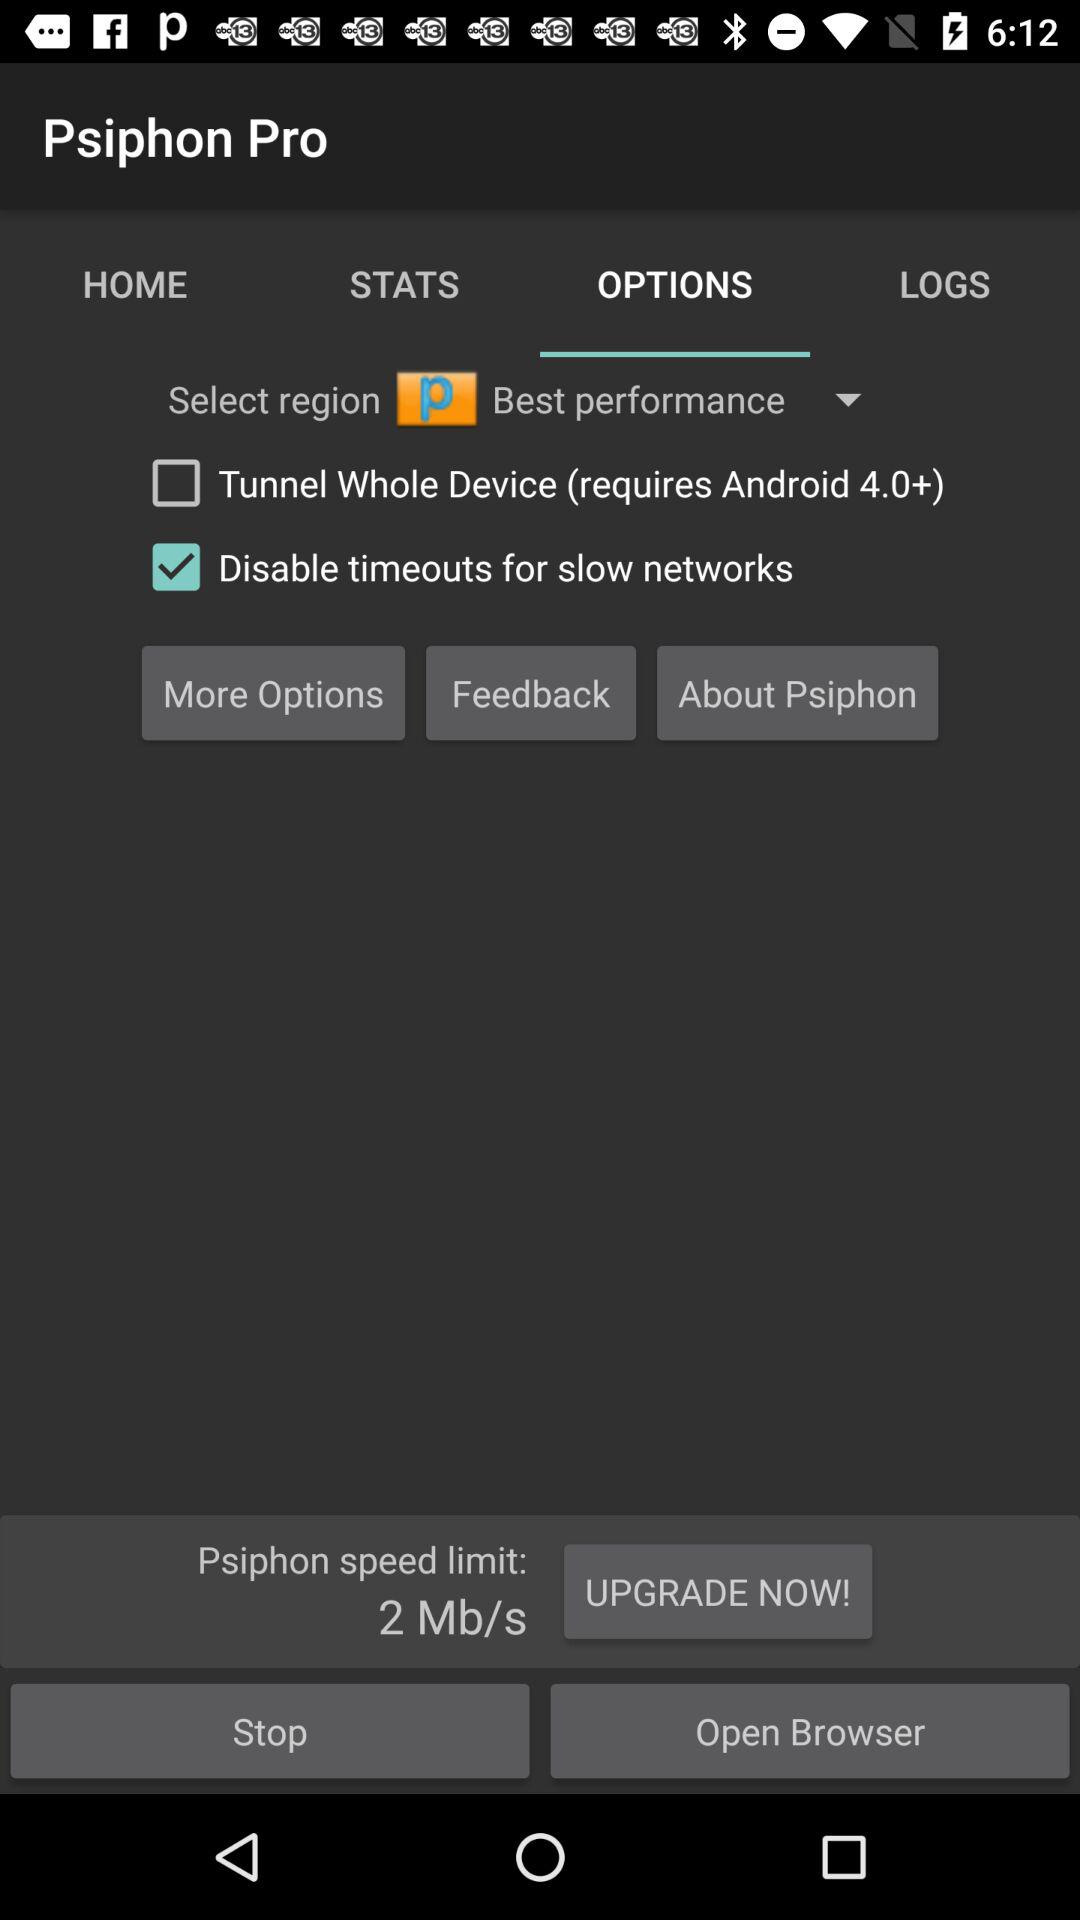What is the "Psiphon" speed limit? The "Psiphon" speed limit is 2 Mb/s. 